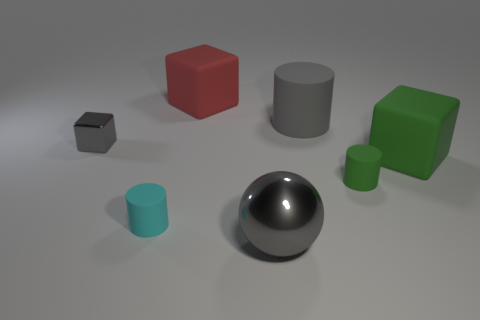Subtract all big green matte blocks. How many blocks are left? 2 Subtract 3 cylinders. How many cylinders are left? 0 Add 2 red matte objects. How many objects exist? 9 Add 3 large red shiny things. How many large red shiny things exist? 3 Subtract 0 brown cylinders. How many objects are left? 7 Subtract all blocks. How many objects are left? 4 Subtract all green blocks. Subtract all red spheres. How many blocks are left? 2 Subtract all gray spheres. How many cyan cylinders are left? 1 Subtract all big red metal spheres. Subtract all small gray things. How many objects are left? 6 Add 5 large green things. How many large green things are left? 6 